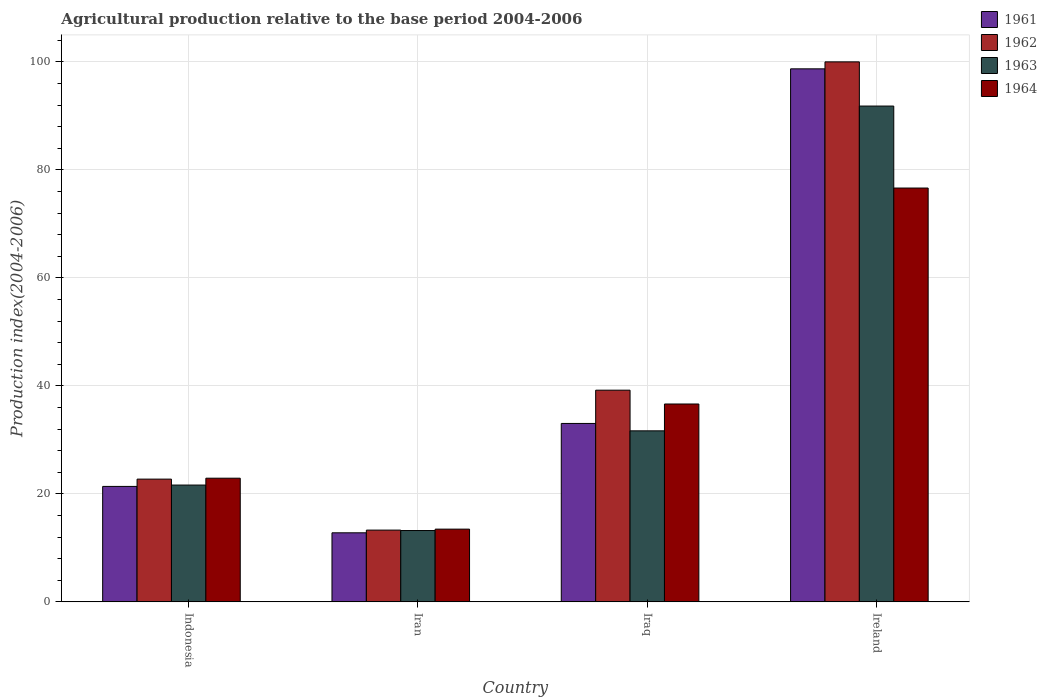How many different coloured bars are there?
Make the answer very short. 4. Are the number of bars per tick equal to the number of legend labels?
Keep it short and to the point. Yes. Are the number of bars on each tick of the X-axis equal?
Provide a succinct answer. Yes. How many bars are there on the 1st tick from the left?
Provide a succinct answer. 4. How many bars are there on the 2nd tick from the right?
Give a very brief answer. 4. What is the label of the 1st group of bars from the left?
Provide a succinct answer. Indonesia. In how many cases, is the number of bars for a given country not equal to the number of legend labels?
Offer a terse response. 0. What is the agricultural production index in 1962 in Iran?
Your answer should be compact. 13.29. Across all countries, what is the maximum agricultural production index in 1963?
Provide a short and direct response. 91.81. Across all countries, what is the minimum agricultural production index in 1961?
Your answer should be very brief. 12.79. In which country was the agricultural production index in 1963 maximum?
Give a very brief answer. Ireland. In which country was the agricultural production index in 1962 minimum?
Offer a terse response. Iran. What is the total agricultural production index in 1961 in the graph?
Offer a terse response. 165.91. What is the difference between the agricultural production index in 1962 in Indonesia and that in Iraq?
Your response must be concise. -16.47. What is the difference between the agricultural production index in 1962 in Iraq and the agricultural production index in 1961 in Ireland?
Make the answer very short. -59.5. What is the average agricultural production index in 1963 per country?
Offer a terse response. 39.58. What is the difference between the agricultural production index of/in 1964 and agricultural production index of/in 1962 in Indonesia?
Give a very brief answer. 0.17. In how many countries, is the agricultural production index in 1964 greater than 72?
Your answer should be very brief. 1. What is the ratio of the agricultural production index in 1964 in Indonesia to that in Ireland?
Make the answer very short. 0.3. Is the agricultural production index in 1964 in Iraq less than that in Ireland?
Your answer should be compact. Yes. What is the difference between the highest and the second highest agricultural production index in 1964?
Give a very brief answer. 39.99. What is the difference between the highest and the lowest agricultural production index in 1963?
Keep it short and to the point. 78.6. In how many countries, is the agricultural production index in 1962 greater than the average agricultural production index in 1962 taken over all countries?
Provide a short and direct response. 1. Is it the case that in every country, the sum of the agricultural production index in 1961 and agricultural production index in 1964 is greater than the sum of agricultural production index in 1962 and agricultural production index in 1963?
Your response must be concise. No. What does the 4th bar from the left in Iran represents?
Provide a succinct answer. 1964. Is it the case that in every country, the sum of the agricultural production index in 1964 and agricultural production index in 1963 is greater than the agricultural production index in 1961?
Keep it short and to the point. Yes. How many bars are there?
Your answer should be compact. 16. Are all the bars in the graph horizontal?
Make the answer very short. No. How many countries are there in the graph?
Provide a short and direct response. 4. Does the graph contain any zero values?
Offer a terse response. No. Does the graph contain grids?
Your answer should be very brief. Yes. How many legend labels are there?
Give a very brief answer. 4. What is the title of the graph?
Keep it short and to the point. Agricultural production relative to the base period 2004-2006. Does "1972" appear as one of the legend labels in the graph?
Your response must be concise. No. What is the label or title of the Y-axis?
Provide a succinct answer. Production index(2004-2006). What is the Production index(2004-2006) of 1961 in Indonesia?
Make the answer very short. 21.38. What is the Production index(2004-2006) of 1962 in Indonesia?
Give a very brief answer. 22.73. What is the Production index(2004-2006) of 1963 in Indonesia?
Keep it short and to the point. 21.63. What is the Production index(2004-2006) of 1964 in Indonesia?
Your answer should be compact. 22.9. What is the Production index(2004-2006) of 1961 in Iran?
Keep it short and to the point. 12.79. What is the Production index(2004-2006) of 1962 in Iran?
Provide a short and direct response. 13.29. What is the Production index(2004-2006) in 1963 in Iran?
Provide a short and direct response. 13.21. What is the Production index(2004-2006) of 1964 in Iran?
Keep it short and to the point. 13.47. What is the Production index(2004-2006) in 1961 in Iraq?
Keep it short and to the point. 33.04. What is the Production index(2004-2006) in 1962 in Iraq?
Give a very brief answer. 39.2. What is the Production index(2004-2006) in 1963 in Iraq?
Offer a terse response. 31.67. What is the Production index(2004-2006) of 1964 in Iraq?
Make the answer very short. 36.64. What is the Production index(2004-2006) of 1961 in Ireland?
Offer a terse response. 98.7. What is the Production index(2004-2006) in 1962 in Ireland?
Provide a succinct answer. 99.99. What is the Production index(2004-2006) of 1963 in Ireland?
Keep it short and to the point. 91.81. What is the Production index(2004-2006) in 1964 in Ireland?
Provide a succinct answer. 76.63. Across all countries, what is the maximum Production index(2004-2006) in 1961?
Your answer should be very brief. 98.7. Across all countries, what is the maximum Production index(2004-2006) in 1962?
Provide a succinct answer. 99.99. Across all countries, what is the maximum Production index(2004-2006) of 1963?
Offer a very short reply. 91.81. Across all countries, what is the maximum Production index(2004-2006) of 1964?
Ensure brevity in your answer.  76.63. Across all countries, what is the minimum Production index(2004-2006) in 1961?
Provide a succinct answer. 12.79. Across all countries, what is the minimum Production index(2004-2006) in 1962?
Your answer should be very brief. 13.29. Across all countries, what is the minimum Production index(2004-2006) of 1963?
Provide a succinct answer. 13.21. Across all countries, what is the minimum Production index(2004-2006) of 1964?
Your answer should be compact. 13.47. What is the total Production index(2004-2006) of 1961 in the graph?
Your response must be concise. 165.91. What is the total Production index(2004-2006) of 1962 in the graph?
Your answer should be compact. 175.21. What is the total Production index(2004-2006) in 1963 in the graph?
Ensure brevity in your answer.  158.32. What is the total Production index(2004-2006) in 1964 in the graph?
Your response must be concise. 149.64. What is the difference between the Production index(2004-2006) in 1961 in Indonesia and that in Iran?
Keep it short and to the point. 8.59. What is the difference between the Production index(2004-2006) of 1962 in Indonesia and that in Iran?
Your response must be concise. 9.44. What is the difference between the Production index(2004-2006) in 1963 in Indonesia and that in Iran?
Your response must be concise. 8.42. What is the difference between the Production index(2004-2006) in 1964 in Indonesia and that in Iran?
Ensure brevity in your answer.  9.43. What is the difference between the Production index(2004-2006) of 1961 in Indonesia and that in Iraq?
Make the answer very short. -11.66. What is the difference between the Production index(2004-2006) in 1962 in Indonesia and that in Iraq?
Ensure brevity in your answer.  -16.47. What is the difference between the Production index(2004-2006) of 1963 in Indonesia and that in Iraq?
Keep it short and to the point. -10.04. What is the difference between the Production index(2004-2006) in 1964 in Indonesia and that in Iraq?
Ensure brevity in your answer.  -13.74. What is the difference between the Production index(2004-2006) in 1961 in Indonesia and that in Ireland?
Provide a short and direct response. -77.32. What is the difference between the Production index(2004-2006) in 1962 in Indonesia and that in Ireland?
Offer a terse response. -77.26. What is the difference between the Production index(2004-2006) of 1963 in Indonesia and that in Ireland?
Make the answer very short. -70.18. What is the difference between the Production index(2004-2006) in 1964 in Indonesia and that in Ireland?
Ensure brevity in your answer.  -53.73. What is the difference between the Production index(2004-2006) of 1961 in Iran and that in Iraq?
Give a very brief answer. -20.25. What is the difference between the Production index(2004-2006) of 1962 in Iran and that in Iraq?
Keep it short and to the point. -25.91. What is the difference between the Production index(2004-2006) of 1963 in Iran and that in Iraq?
Your response must be concise. -18.46. What is the difference between the Production index(2004-2006) in 1964 in Iran and that in Iraq?
Offer a terse response. -23.17. What is the difference between the Production index(2004-2006) in 1961 in Iran and that in Ireland?
Keep it short and to the point. -85.91. What is the difference between the Production index(2004-2006) of 1962 in Iran and that in Ireland?
Your response must be concise. -86.7. What is the difference between the Production index(2004-2006) of 1963 in Iran and that in Ireland?
Your response must be concise. -78.6. What is the difference between the Production index(2004-2006) of 1964 in Iran and that in Ireland?
Provide a succinct answer. -63.16. What is the difference between the Production index(2004-2006) of 1961 in Iraq and that in Ireland?
Make the answer very short. -65.66. What is the difference between the Production index(2004-2006) in 1962 in Iraq and that in Ireland?
Your response must be concise. -60.79. What is the difference between the Production index(2004-2006) in 1963 in Iraq and that in Ireland?
Your response must be concise. -60.14. What is the difference between the Production index(2004-2006) of 1964 in Iraq and that in Ireland?
Your answer should be very brief. -39.99. What is the difference between the Production index(2004-2006) of 1961 in Indonesia and the Production index(2004-2006) of 1962 in Iran?
Make the answer very short. 8.09. What is the difference between the Production index(2004-2006) in 1961 in Indonesia and the Production index(2004-2006) in 1963 in Iran?
Make the answer very short. 8.17. What is the difference between the Production index(2004-2006) in 1961 in Indonesia and the Production index(2004-2006) in 1964 in Iran?
Keep it short and to the point. 7.91. What is the difference between the Production index(2004-2006) in 1962 in Indonesia and the Production index(2004-2006) in 1963 in Iran?
Your answer should be compact. 9.52. What is the difference between the Production index(2004-2006) in 1962 in Indonesia and the Production index(2004-2006) in 1964 in Iran?
Ensure brevity in your answer.  9.26. What is the difference between the Production index(2004-2006) in 1963 in Indonesia and the Production index(2004-2006) in 1964 in Iran?
Offer a very short reply. 8.16. What is the difference between the Production index(2004-2006) in 1961 in Indonesia and the Production index(2004-2006) in 1962 in Iraq?
Your answer should be compact. -17.82. What is the difference between the Production index(2004-2006) of 1961 in Indonesia and the Production index(2004-2006) of 1963 in Iraq?
Ensure brevity in your answer.  -10.29. What is the difference between the Production index(2004-2006) of 1961 in Indonesia and the Production index(2004-2006) of 1964 in Iraq?
Provide a succinct answer. -15.26. What is the difference between the Production index(2004-2006) of 1962 in Indonesia and the Production index(2004-2006) of 1963 in Iraq?
Give a very brief answer. -8.94. What is the difference between the Production index(2004-2006) in 1962 in Indonesia and the Production index(2004-2006) in 1964 in Iraq?
Keep it short and to the point. -13.91. What is the difference between the Production index(2004-2006) in 1963 in Indonesia and the Production index(2004-2006) in 1964 in Iraq?
Your answer should be very brief. -15.01. What is the difference between the Production index(2004-2006) of 1961 in Indonesia and the Production index(2004-2006) of 1962 in Ireland?
Give a very brief answer. -78.61. What is the difference between the Production index(2004-2006) in 1961 in Indonesia and the Production index(2004-2006) in 1963 in Ireland?
Provide a short and direct response. -70.43. What is the difference between the Production index(2004-2006) in 1961 in Indonesia and the Production index(2004-2006) in 1964 in Ireland?
Your answer should be very brief. -55.25. What is the difference between the Production index(2004-2006) of 1962 in Indonesia and the Production index(2004-2006) of 1963 in Ireland?
Your answer should be very brief. -69.08. What is the difference between the Production index(2004-2006) in 1962 in Indonesia and the Production index(2004-2006) in 1964 in Ireland?
Ensure brevity in your answer.  -53.9. What is the difference between the Production index(2004-2006) of 1963 in Indonesia and the Production index(2004-2006) of 1964 in Ireland?
Ensure brevity in your answer.  -55. What is the difference between the Production index(2004-2006) in 1961 in Iran and the Production index(2004-2006) in 1962 in Iraq?
Provide a succinct answer. -26.41. What is the difference between the Production index(2004-2006) in 1961 in Iran and the Production index(2004-2006) in 1963 in Iraq?
Your answer should be very brief. -18.88. What is the difference between the Production index(2004-2006) of 1961 in Iran and the Production index(2004-2006) of 1964 in Iraq?
Give a very brief answer. -23.85. What is the difference between the Production index(2004-2006) of 1962 in Iran and the Production index(2004-2006) of 1963 in Iraq?
Your answer should be very brief. -18.38. What is the difference between the Production index(2004-2006) of 1962 in Iran and the Production index(2004-2006) of 1964 in Iraq?
Your answer should be very brief. -23.35. What is the difference between the Production index(2004-2006) of 1963 in Iran and the Production index(2004-2006) of 1964 in Iraq?
Make the answer very short. -23.43. What is the difference between the Production index(2004-2006) in 1961 in Iran and the Production index(2004-2006) in 1962 in Ireland?
Provide a succinct answer. -87.2. What is the difference between the Production index(2004-2006) in 1961 in Iran and the Production index(2004-2006) in 1963 in Ireland?
Your answer should be compact. -79.02. What is the difference between the Production index(2004-2006) in 1961 in Iran and the Production index(2004-2006) in 1964 in Ireland?
Offer a terse response. -63.84. What is the difference between the Production index(2004-2006) of 1962 in Iran and the Production index(2004-2006) of 1963 in Ireland?
Your answer should be very brief. -78.52. What is the difference between the Production index(2004-2006) in 1962 in Iran and the Production index(2004-2006) in 1964 in Ireland?
Your answer should be compact. -63.34. What is the difference between the Production index(2004-2006) in 1963 in Iran and the Production index(2004-2006) in 1964 in Ireland?
Offer a terse response. -63.42. What is the difference between the Production index(2004-2006) of 1961 in Iraq and the Production index(2004-2006) of 1962 in Ireland?
Your response must be concise. -66.95. What is the difference between the Production index(2004-2006) in 1961 in Iraq and the Production index(2004-2006) in 1963 in Ireland?
Your answer should be very brief. -58.77. What is the difference between the Production index(2004-2006) in 1961 in Iraq and the Production index(2004-2006) in 1964 in Ireland?
Give a very brief answer. -43.59. What is the difference between the Production index(2004-2006) in 1962 in Iraq and the Production index(2004-2006) in 1963 in Ireland?
Your answer should be very brief. -52.61. What is the difference between the Production index(2004-2006) in 1962 in Iraq and the Production index(2004-2006) in 1964 in Ireland?
Offer a terse response. -37.43. What is the difference between the Production index(2004-2006) in 1963 in Iraq and the Production index(2004-2006) in 1964 in Ireland?
Make the answer very short. -44.96. What is the average Production index(2004-2006) of 1961 per country?
Your answer should be compact. 41.48. What is the average Production index(2004-2006) in 1962 per country?
Your answer should be compact. 43.8. What is the average Production index(2004-2006) in 1963 per country?
Offer a very short reply. 39.58. What is the average Production index(2004-2006) of 1964 per country?
Your response must be concise. 37.41. What is the difference between the Production index(2004-2006) of 1961 and Production index(2004-2006) of 1962 in Indonesia?
Your response must be concise. -1.35. What is the difference between the Production index(2004-2006) of 1961 and Production index(2004-2006) of 1964 in Indonesia?
Give a very brief answer. -1.52. What is the difference between the Production index(2004-2006) of 1962 and Production index(2004-2006) of 1963 in Indonesia?
Offer a very short reply. 1.1. What is the difference between the Production index(2004-2006) of 1962 and Production index(2004-2006) of 1964 in Indonesia?
Offer a terse response. -0.17. What is the difference between the Production index(2004-2006) of 1963 and Production index(2004-2006) of 1964 in Indonesia?
Keep it short and to the point. -1.27. What is the difference between the Production index(2004-2006) in 1961 and Production index(2004-2006) in 1963 in Iran?
Provide a succinct answer. -0.42. What is the difference between the Production index(2004-2006) of 1961 and Production index(2004-2006) of 1964 in Iran?
Provide a succinct answer. -0.68. What is the difference between the Production index(2004-2006) in 1962 and Production index(2004-2006) in 1963 in Iran?
Your answer should be very brief. 0.08. What is the difference between the Production index(2004-2006) of 1962 and Production index(2004-2006) of 1964 in Iran?
Offer a very short reply. -0.18. What is the difference between the Production index(2004-2006) in 1963 and Production index(2004-2006) in 1964 in Iran?
Your answer should be very brief. -0.26. What is the difference between the Production index(2004-2006) of 1961 and Production index(2004-2006) of 1962 in Iraq?
Make the answer very short. -6.16. What is the difference between the Production index(2004-2006) of 1961 and Production index(2004-2006) of 1963 in Iraq?
Offer a very short reply. 1.37. What is the difference between the Production index(2004-2006) in 1961 and Production index(2004-2006) in 1964 in Iraq?
Your response must be concise. -3.6. What is the difference between the Production index(2004-2006) of 1962 and Production index(2004-2006) of 1963 in Iraq?
Your response must be concise. 7.53. What is the difference between the Production index(2004-2006) in 1962 and Production index(2004-2006) in 1964 in Iraq?
Your response must be concise. 2.56. What is the difference between the Production index(2004-2006) in 1963 and Production index(2004-2006) in 1964 in Iraq?
Give a very brief answer. -4.97. What is the difference between the Production index(2004-2006) in 1961 and Production index(2004-2006) in 1962 in Ireland?
Keep it short and to the point. -1.29. What is the difference between the Production index(2004-2006) in 1961 and Production index(2004-2006) in 1963 in Ireland?
Provide a short and direct response. 6.89. What is the difference between the Production index(2004-2006) of 1961 and Production index(2004-2006) of 1964 in Ireland?
Provide a succinct answer. 22.07. What is the difference between the Production index(2004-2006) in 1962 and Production index(2004-2006) in 1963 in Ireland?
Your answer should be compact. 8.18. What is the difference between the Production index(2004-2006) in 1962 and Production index(2004-2006) in 1964 in Ireland?
Ensure brevity in your answer.  23.36. What is the difference between the Production index(2004-2006) in 1963 and Production index(2004-2006) in 1964 in Ireland?
Offer a terse response. 15.18. What is the ratio of the Production index(2004-2006) of 1961 in Indonesia to that in Iran?
Make the answer very short. 1.67. What is the ratio of the Production index(2004-2006) in 1962 in Indonesia to that in Iran?
Keep it short and to the point. 1.71. What is the ratio of the Production index(2004-2006) in 1963 in Indonesia to that in Iran?
Make the answer very short. 1.64. What is the ratio of the Production index(2004-2006) in 1964 in Indonesia to that in Iran?
Offer a terse response. 1.7. What is the ratio of the Production index(2004-2006) of 1961 in Indonesia to that in Iraq?
Provide a succinct answer. 0.65. What is the ratio of the Production index(2004-2006) in 1962 in Indonesia to that in Iraq?
Make the answer very short. 0.58. What is the ratio of the Production index(2004-2006) of 1963 in Indonesia to that in Iraq?
Your response must be concise. 0.68. What is the ratio of the Production index(2004-2006) of 1961 in Indonesia to that in Ireland?
Make the answer very short. 0.22. What is the ratio of the Production index(2004-2006) in 1962 in Indonesia to that in Ireland?
Your response must be concise. 0.23. What is the ratio of the Production index(2004-2006) of 1963 in Indonesia to that in Ireland?
Your answer should be compact. 0.24. What is the ratio of the Production index(2004-2006) in 1964 in Indonesia to that in Ireland?
Ensure brevity in your answer.  0.3. What is the ratio of the Production index(2004-2006) of 1961 in Iran to that in Iraq?
Provide a succinct answer. 0.39. What is the ratio of the Production index(2004-2006) of 1962 in Iran to that in Iraq?
Make the answer very short. 0.34. What is the ratio of the Production index(2004-2006) in 1963 in Iran to that in Iraq?
Ensure brevity in your answer.  0.42. What is the ratio of the Production index(2004-2006) of 1964 in Iran to that in Iraq?
Offer a terse response. 0.37. What is the ratio of the Production index(2004-2006) in 1961 in Iran to that in Ireland?
Make the answer very short. 0.13. What is the ratio of the Production index(2004-2006) of 1962 in Iran to that in Ireland?
Make the answer very short. 0.13. What is the ratio of the Production index(2004-2006) in 1963 in Iran to that in Ireland?
Give a very brief answer. 0.14. What is the ratio of the Production index(2004-2006) of 1964 in Iran to that in Ireland?
Offer a very short reply. 0.18. What is the ratio of the Production index(2004-2006) of 1961 in Iraq to that in Ireland?
Ensure brevity in your answer.  0.33. What is the ratio of the Production index(2004-2006) of 1962 in Iraq to that in Ireland?
Ensure brevity in your answer.  0.39. What is the ratio of the Production index(2004-2006) of 1963 in Iraq to that in Ireland?
Provide a succinct answer. 0.34. What is the ratio of the Production index(2004-2006) in 1964 in Iraq to that in Ireland?
Make the answer very short. 0.48. What is the difference between the highest and the second highest Production index(2004-2006) in 1961?
Ensure brevity in your answer.  65.66. What is the difference between the highest and the second highest Production index(2004-2006) in 1962?
Make the answer very short. 60.79. What is the difference between the highest and the second highest Production index(2004-2006) of 1963?
Your answer should be compact. 60.14. What is the difference between the highest and the second highest Production index(2004-2006) of 1964?
Make the answer very short. 39.99. What is the difference between the highest and the lowest Production index(2004-2006) of 1961?
Offer a terse response. 85.91. What is the difference between the highest and the lowest Production index(2004-2006) of 1962?
Keep it short and to the point. 86.7. What is the difference between the highest and the lowest Production index(2004-2006) in 1963?
Provide a succinct answer. 78.6. What is the difference between the highest and the lowest Production index(2004-2006) in 1964?
Offer a terse response. 63.16. 